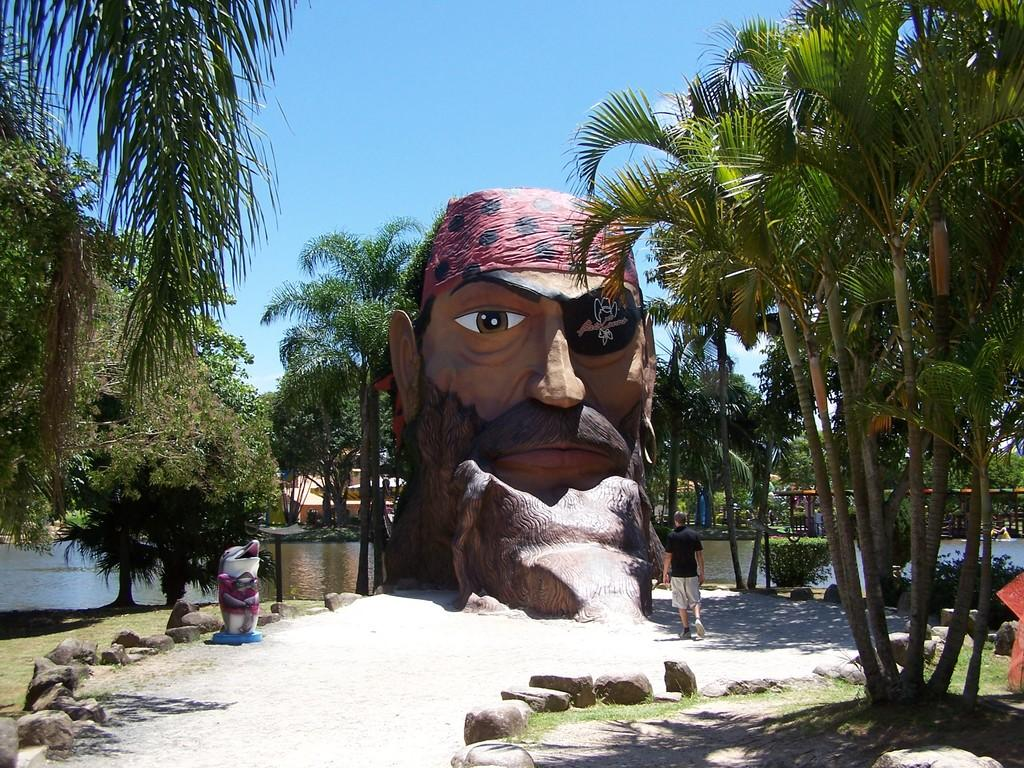What is the main subject of the image? There is a statue of a head in the image. What else can be seen in the image besides the statue? There is a path, a person walking, green color trees, and a blue sky in the image. Can you describe the person's activity in the image? A person is walking in the image. What is the color of the trees in the image? The trees in the image are green. What is the color of the sky in the image? The sky is blue in the image. How many geese are flying in the image? There are no geese present in the image. What type of tool is the person using to fix the statue in the image? There is no tool or repair activity depicted in the image; the person is simply walking. 